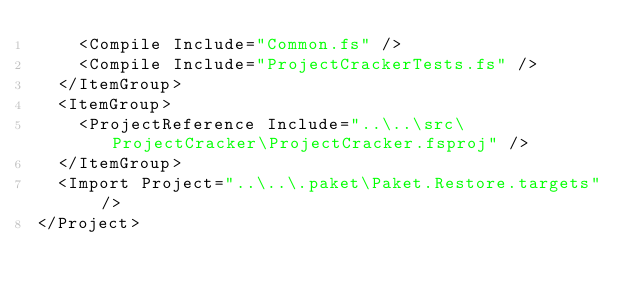Convert code to text. <code><loc_0><loc_0><loc_500><loc_500><_XML_>    <Compile Include="Common.fs" />
    <Compile Include="ProjectCrackerTests.fs" />
  </ItemGroup>
  <ItemGroup>
    <ProjectReference Include="..\..\src\ProjectCracker\ProjectCracker.fsproj" />
  </ItemGroup>
  <Import Project="..\..\.paket\Paket.Restore.targets" />
</Project></code> 